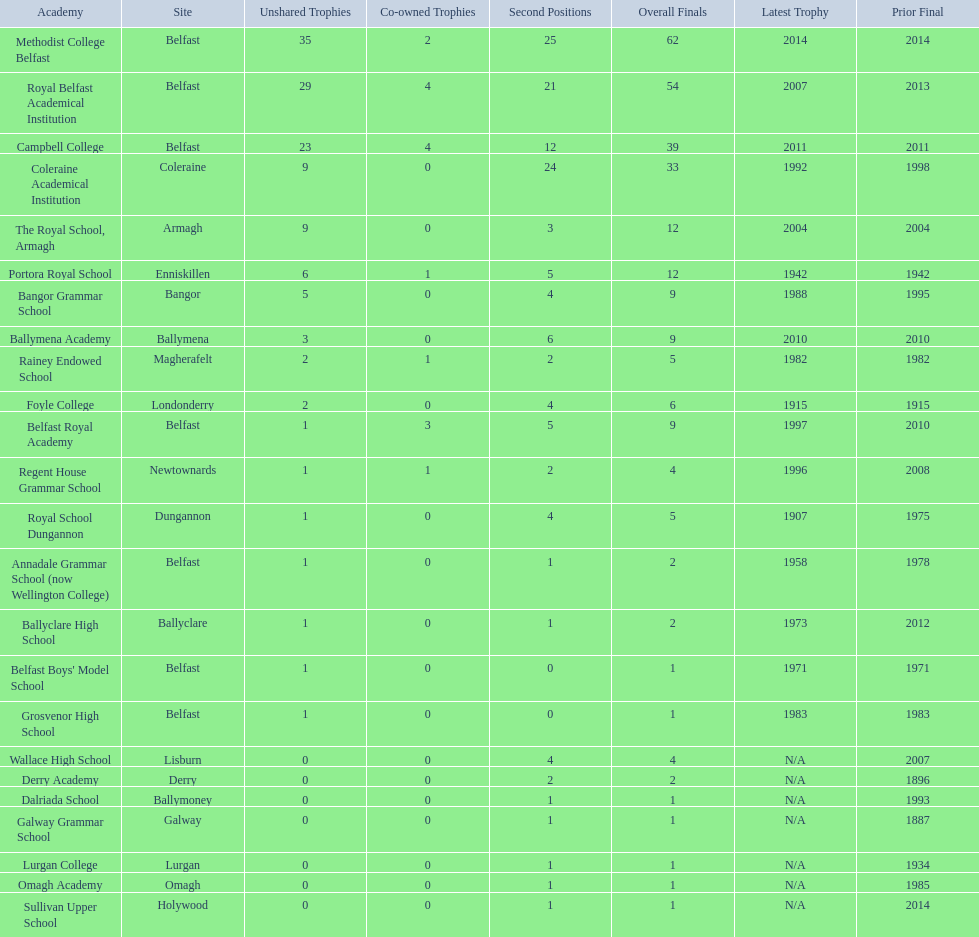How many outright titles does coleraine academical institution have? 9. What other school has this amount of outright titles The Royal School, Armagh. Could you parse the entire table as a dict? {'header': ['Academy', 'Site', 'Unshared Trophies', 'Co-owned Trophies', 'Second Positions', 'Overall Finals', 'Latest Trophy', 'Prior Final'], 'rows': [['Methodist College Belfast', 'Belfast', '35', '2', '25', '62', '2014', '2014'], ['Royal Belfast Academical Institution', 'Belfast', '29', '4', '21', '54', '2007', '2013'], ['Campbell College', 'Belfast', '23', '4', '12', '39', '2011', '2011'], ['Coleraine Academical Institution', 'Coleraine', '9', '0', '24', '33', '1992', '1998'], ['The Royal School, Armagh', 'Armagh', '9', '0', '3', '12', '2004', '2004'], ['Portora Royal School', 'Enniskillen', '6', '1', '5', '12', '1942', '1942'], ['Bangor Grammar School', 'Bangor', '5', '0', '4', '9', '1988', '1995'], ['Ballymena Academy', 'Ballymena', '3', '0', '6', '9', '2010', '2010'], ['Rainey Endowed School', 'Magherafelt', '2', '1', '2', '5', '1982', '1982'], ['Foyle College', 'Londonderry', '2', '0', '4', '6', '1915', '1915'], ['Belfast Royal Academy', 'Belfast', '1', '3', '5', '9', '1997', '2010'], ['Regent House Grammar School', 'Newtownards', '1', '1', '2', '4', '1996', '2008'], ['Royal School Dungannon', 'Dungannon', '1', '0', '4', '5', '1907', '1975'], ['Annadale Grammar School (now Wellington College)', 'Belfast', '1', '0', '1', '2', '1958', '1978'], ['Ballyclare High School', 'Ballyclare', '1', '0', '1', '2', '1973', '2012'], ["Belfast Boys' Model School", 'Belfast', '1', '0', '0', '1', '1971', '1971'], ['Grosvenor High School', 'Belfast', '1', '0', '0', '1', '1983', '1983'], ['Wallace High School', 'Lisburn', '0', '0', '4', '4', 'N/A', '2007'], ['Derry Academy', 'Derry', '0', '0', '2', '2', 'N/A', '1896'], ['Dalriada School', 'Ballymoney', '0', '0', '1', '1', 'N/A', '1993'], ['Galway Grammar School', 'Galway', '0', '0', '1', '1', 'N/A', '1887'], ['Lurgan College', 'Lurgan', '0', '0', '1', '1', 'N/A', '1934'], ['Omagh Academy', 'Omagh', '0', '0', '1', '1', 'N/A', '1985'], ['Sullivan Upper School', 'Holywood', '0', '0', '1', '1', 'N/A', '2014']]} 